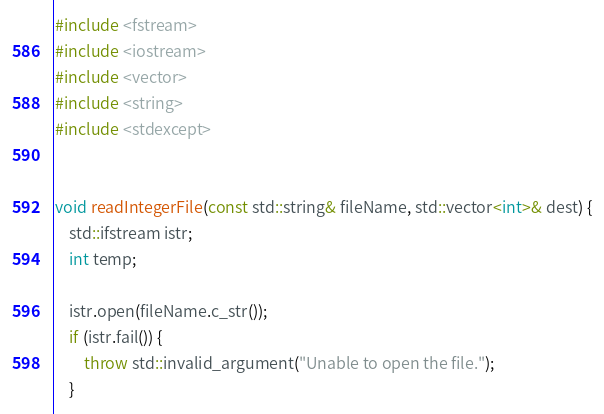<code> <loc_0><loc_0><loc_500><loc_500><_C++_>#include <fstream>
#include <iostream>
#include <vector>
#include <string>
#include <stdexcept>


void readIntegerFile(const std::string& fileName, std::vector<int>& dest) {
    std::ifstream istr;
    int temp;

    istr.open(fileName.c_str());
    if (istr.fail()) {
        throw std::invalid_argument("Unable to open the file.");
    }
</code> 